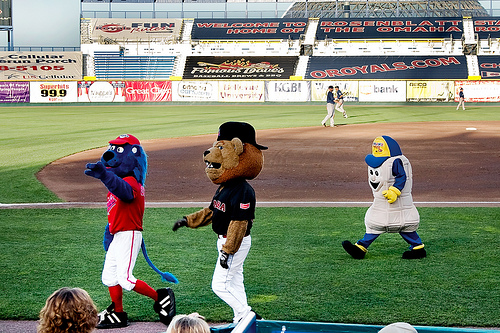<image>
Is there a peanut on the grass? Yes. Looking at the image, I can see the peanut is positioned on top of the grass, with the grass providing support. 